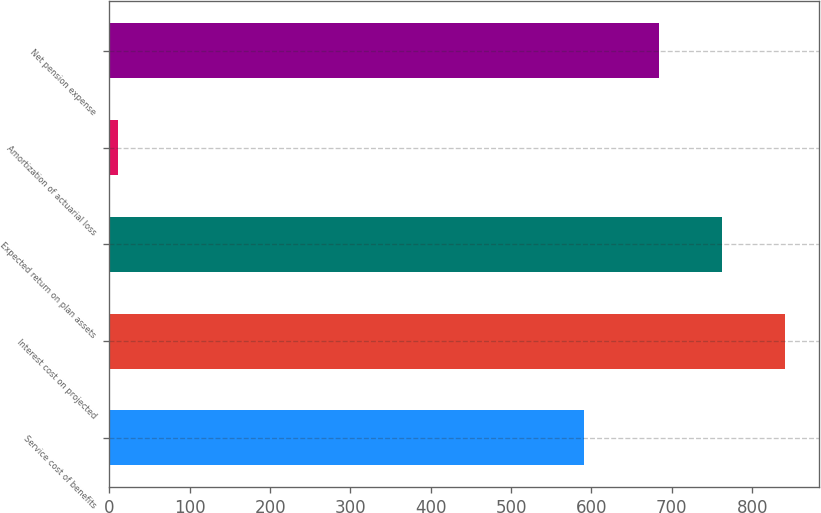Convert chart. <chart><loc_0><loc_0><loc_500><loc_500><bar_chart><fcel>Service cost of benefits<fcel>Interest cost on projected<fcel>Expected return on plan assets<fcel>Amortization of actuarial loss<fcel>Net pension expense<nl><fcel>591<fcel>841<fcel>762.5<fcel>11<fcel>684<nl></chart> 